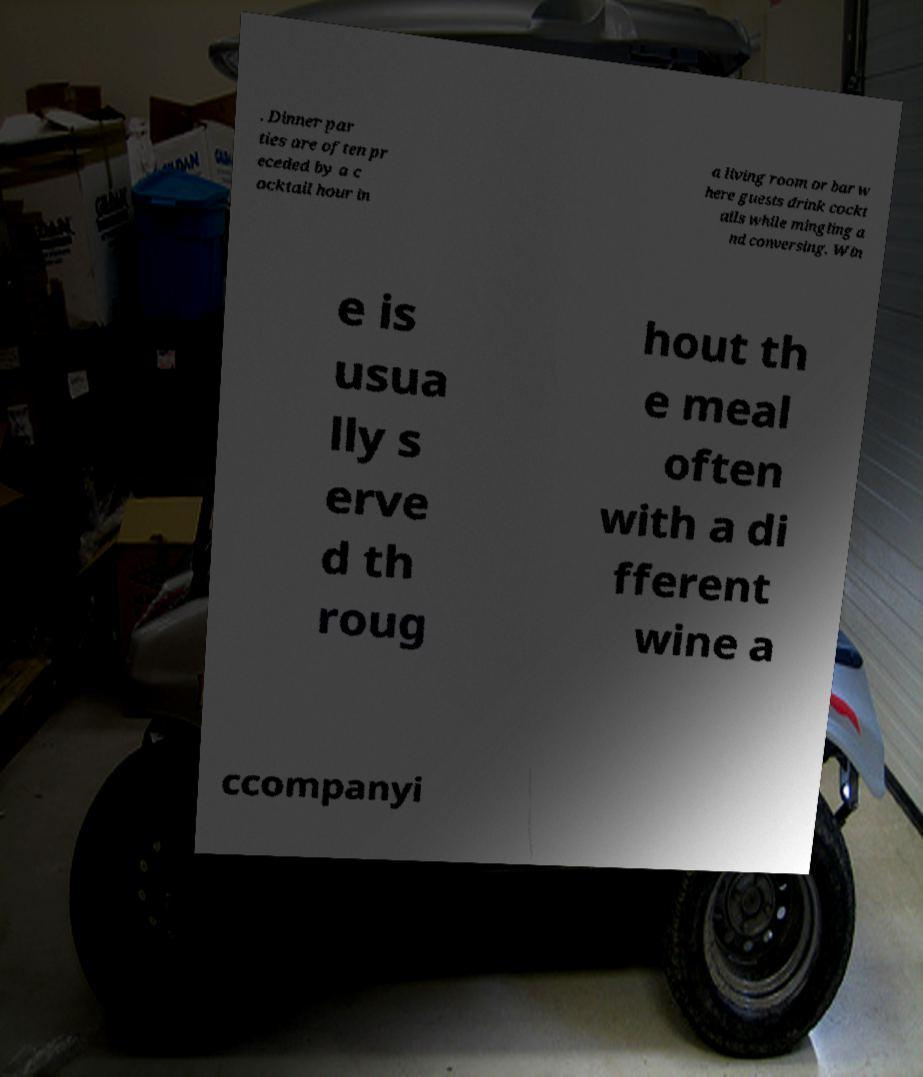For documentation purposes, I need the text within this image transcribed. Could you provide that? . Dinner par ties are often pr eceded by a c ocktail hour in a living room or bar w here guests drink cockt ails while mingling a nd conversing. Win e is usua lly s erve d th roug hout th e meal often with a di fferent wine a ccompanyi 